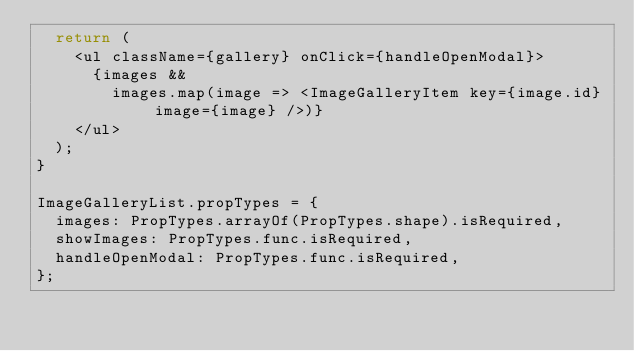Convert code to text. <code><loc_0><loc_0><loc_500><loc_500><_JavaScript_>  return (
    <ul className={gallery} onClick={handleOpenModal}>
      {images &&
        images.map(image => <ImageGalleryItem key={image.id} image={image} />)}
    </ul>
  );
}

ImageGalleryList.propTypes = {
  images: PropTypes.arrayOf(PropTypes.shape).isRequired,
  showImages: PropTypes.func.isRequired,
  handleOpenModal: PropTypes.func.isRequired,
};
</code> 